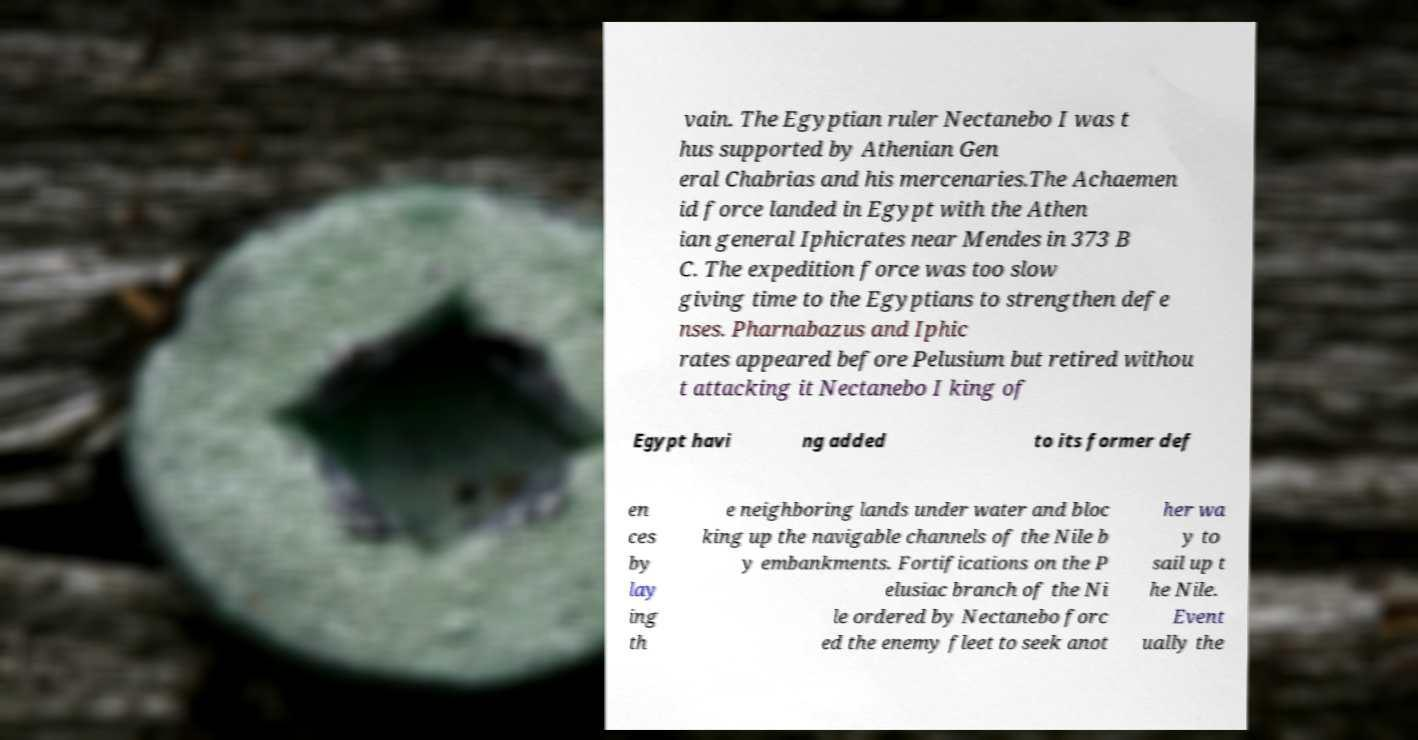Please identify and transcribe the text found in this image. vain. The Egyptian ruler Nectanebo I was t hus supported by Athenian Gen eral Chabrias and his mercenaries.The Achaemen id force landed in Egypt with the Athen ian general Iphicrates near Mendes in 373 B C. The expedition force was too slow giving time to the Egyptians to strengthen defe nses. Pharnabazus and Iphic rates appeared before Pelusium but retired withou t attacking it Nectanebo I king of Egypt havi ng added to its former def en ces by lay ing th e neighboring lands under water and bloc king up the navigable channels of the Nile b y embankments. Fortifications on the P elusiac branch of the Ni le ordered by Nectanebo forc ed the enemy fleet to seek anot her wa y to sail up t he Nile. Event ually the 